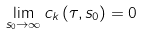Convert formula to latex. <formula><loc_0><loc_0><loc_500><loc_500>\lim _ { s _ { 0 } \to \infty } c _ { k } \left ( \tau , s _ { 0 } \right ) = 0</formula> 